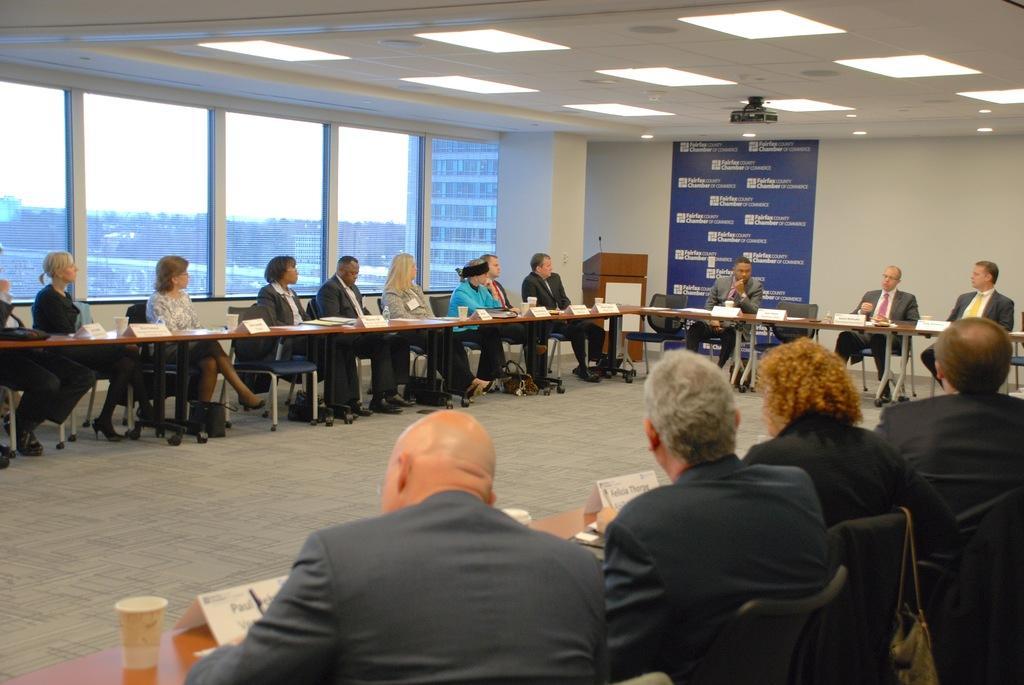Describe this image in one or two sentences. in the picture we can see a room having a meeting,the people were sitting in the chair having tables in front of them,there are many items present on the table,we can also see buildings from the window,we can also see clear sky through the window. 